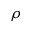<formula> <loc_0><loc_0><loc_500><loc_500>\rho</formula> 